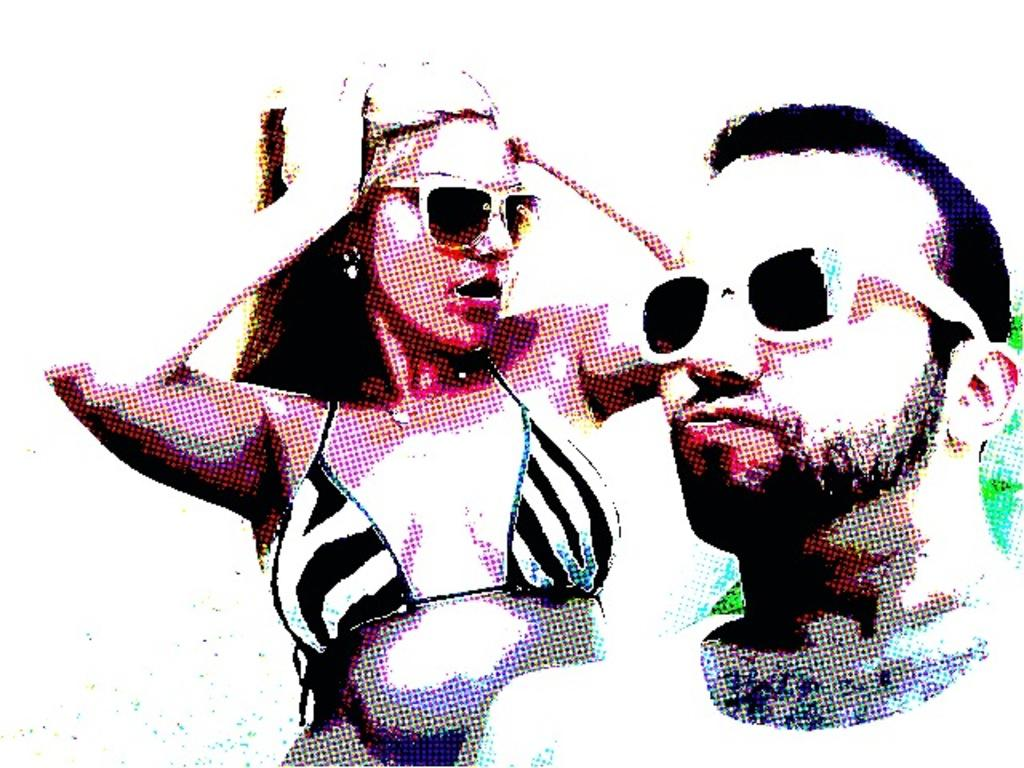How many people are in the image? There are two people in the image, a man and a woman. What are the man and woman wearing on their faces? The man and woman are both wearing goggles. What type of accessory is the woman wearing? The woman is wearing earrings. What is the nature of the image? The image is an animated picture. What type of bucket is the man using to spy on the woman in the image? There is no bucket or spying activity present in the image. 